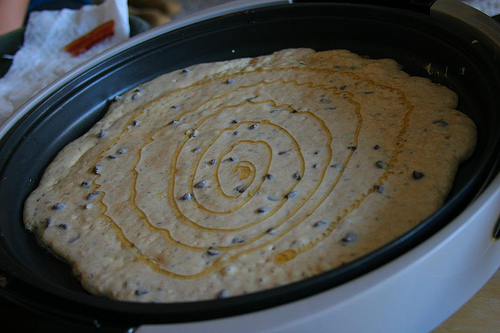<image>
Can you confirm if the pancake is next to the pan? No. The pancake is not positioned next to the pan. They are located in different areas of the scene. 